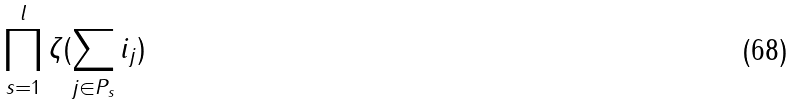<formula> <loc_0><loc_0><loc_500><loc_500>\prod _ { s = 1 } ^ { l } \zeta ( \sum _ { j \in P _ { s } } i _ { j } )</formula> 